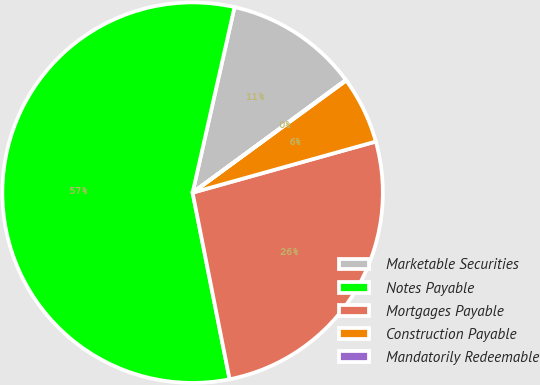<chart> <loc_0><loc_0><loc_500><loc_500><pie_chart><fcel>Marketable Securities<fcel>Notes Payable<fcel>Mortgages Payable<fcel>Construction Payable<fcel>Mandatorily Redeemable<nl><fcel>11.37%<fcel>56.65%<fcel>26.21%<fcel>5.71%<fcel>0.05%<nl></chart> 